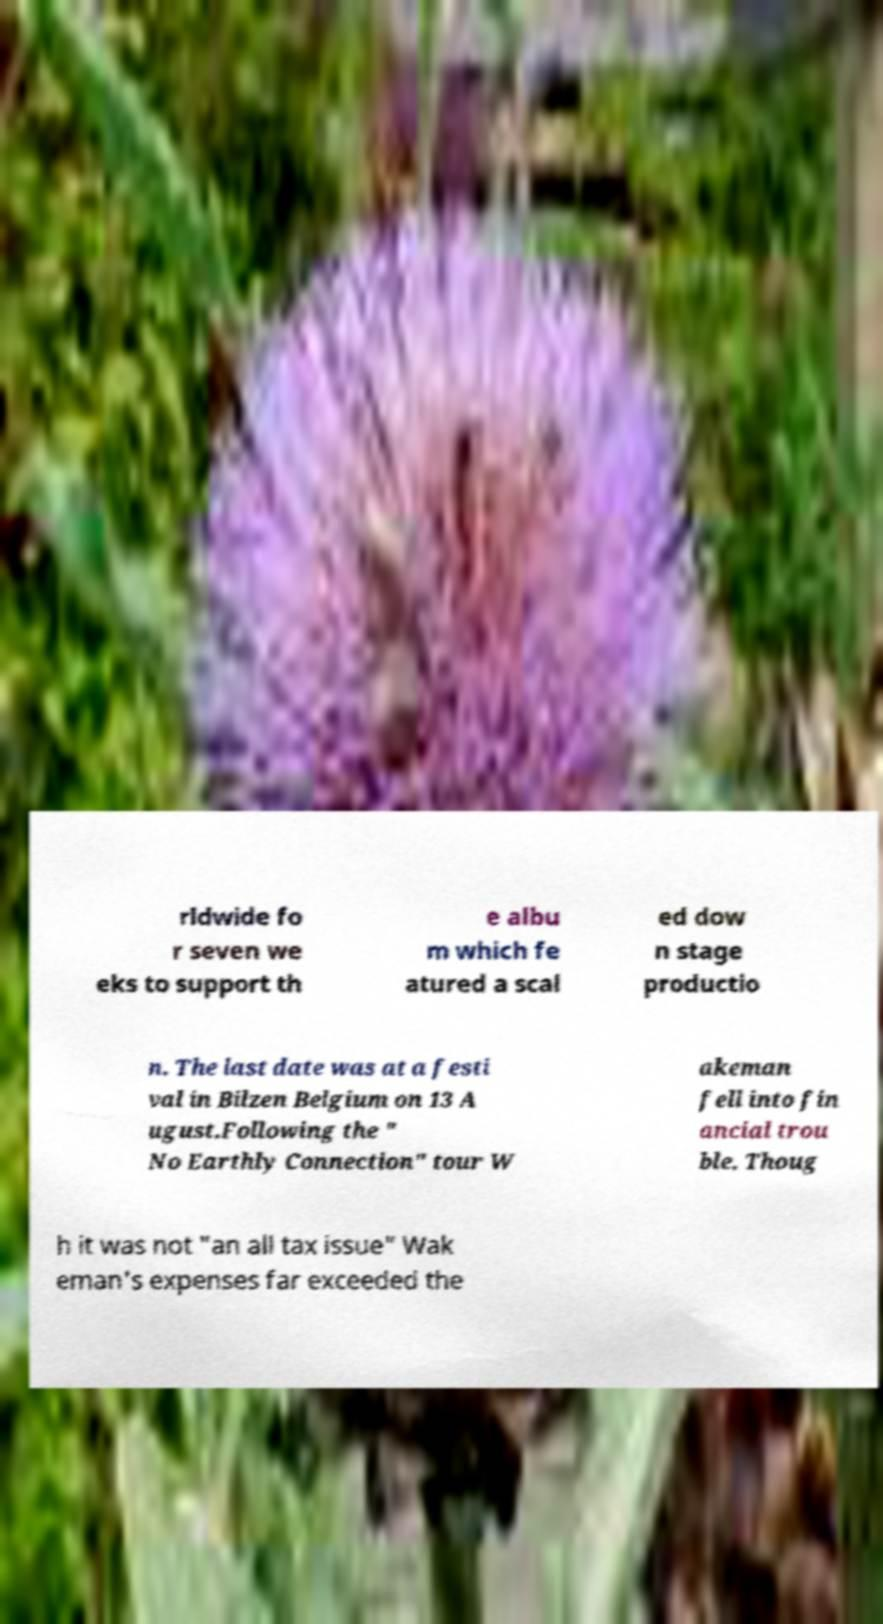Please read and relay the text visible in this image. What does it say? rldwide fo r seven we eks to support th e albu m which fe atured a scal ed dow n stage productio n. The last date was at a festi val in Bilzen Belgium on 13 A ugust.Following the " No Earthly Connection" tour W akeman fell into fin ancial trou ble. Thoug h it was not "an all tax issue" Wak eman's expenses far exceeded the 